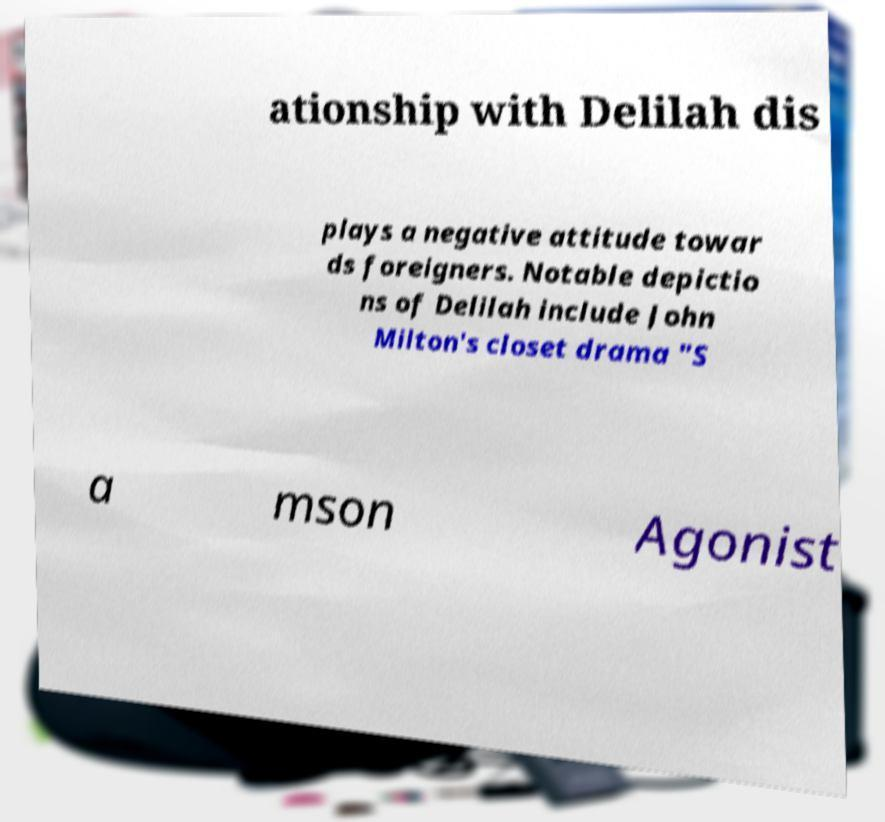Please identify and transcribe the text found in this image. ationship with Delilah dis plays a negative attitude towar ds foreigners. Notable depictio ns of Delilah include John Milton's closet drama "S a mson Agonist 